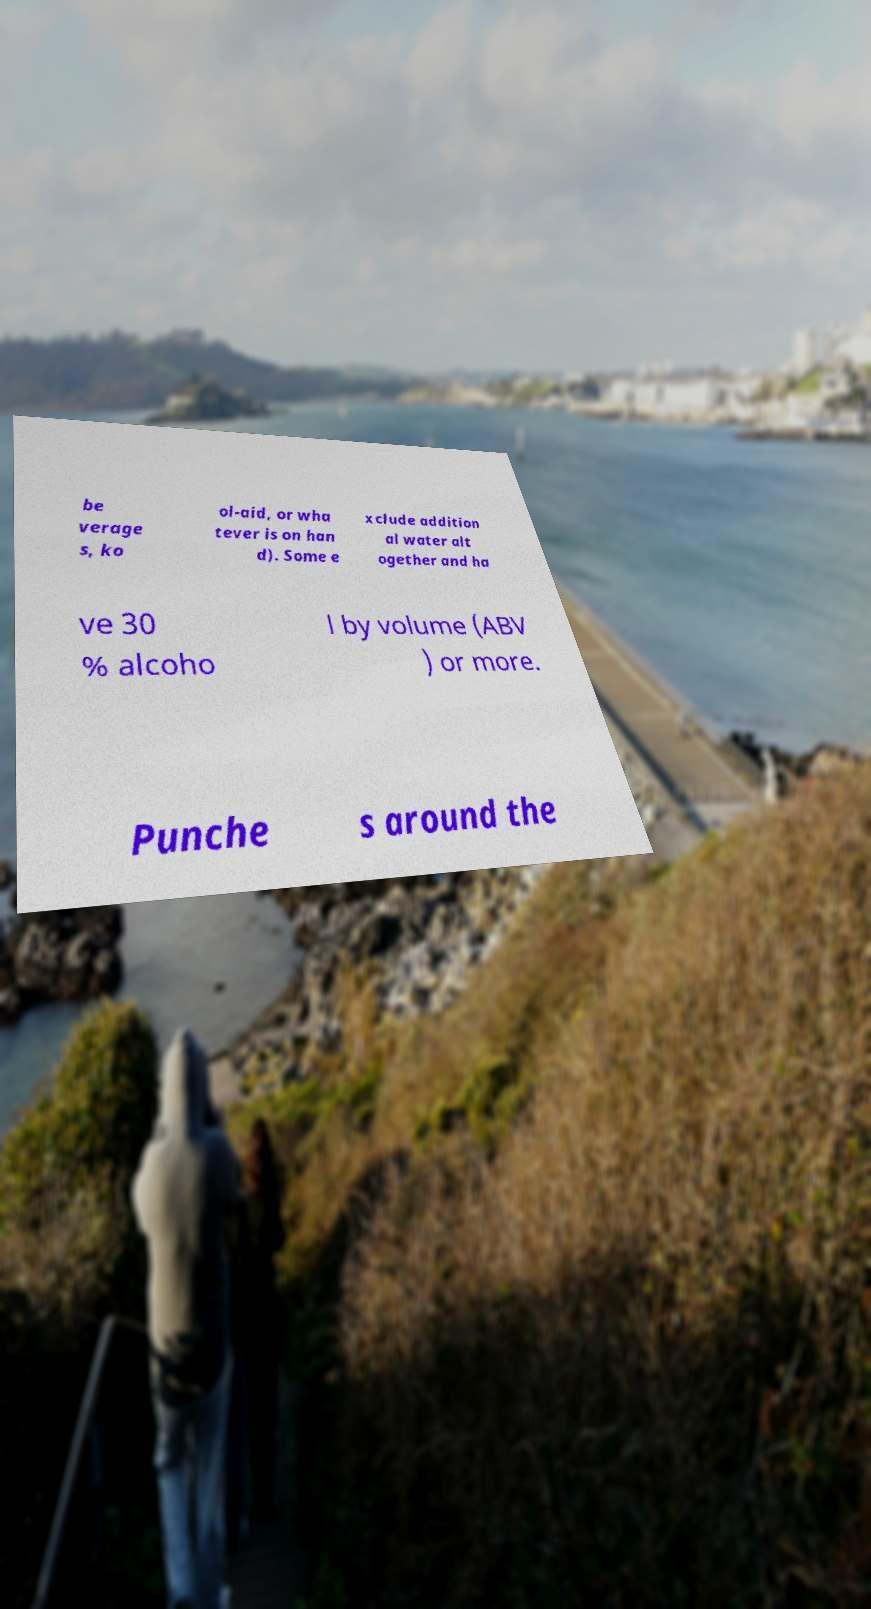Can you read and provide the text displayed in the image?This photo seems to have some interesting text. Can you extract and type it out for me? be verage s, ko ol-aid, or wha tever is on han d). Some e xclude addition al water alt ogether and ha ve 30 % alcoho l by volume (ABV ) or more. Punche s around the 